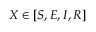<formula> <loc_0><loc_0><loc_500><loc_500>X \in [ S , E , I , R ]</formula> 